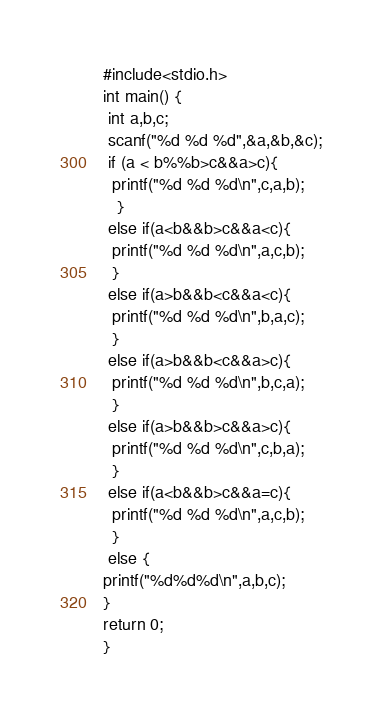Convert code to text. <code><loc_0><loc_0><loc_500><loc_500><_C++_>#include<stdio.h>
int main() {
 int a,b,c;
 scanf("%d %d %d",&a,&b,&c);
 if (a < b%%b>c&&a>c){
  printf("%d %d %d\n",c,a,b);
   }
 else if(a<b&&b>c&&a<c){
  printf("%d %d %d\n",a,c,b);
  }
 else if(a>b&&b<c&&a<c){
  printf("%d %d %d\n",b,a,c);
  }
 else if(a>b&&b<c&&a>c){
  printf("%d %d %d\n",b,c,a);
  }
 else if(a>b&&b>c&&a>c){
  printf("%d %d %d\n",c,b,a);
  }
 else if(a<b&&b>c&&a=c){
  printf("%d %d %d\n",a,c,b);
  }
 else {
printf("%d%d%d\n",a,b,c);
}
return 0;
}</code> 